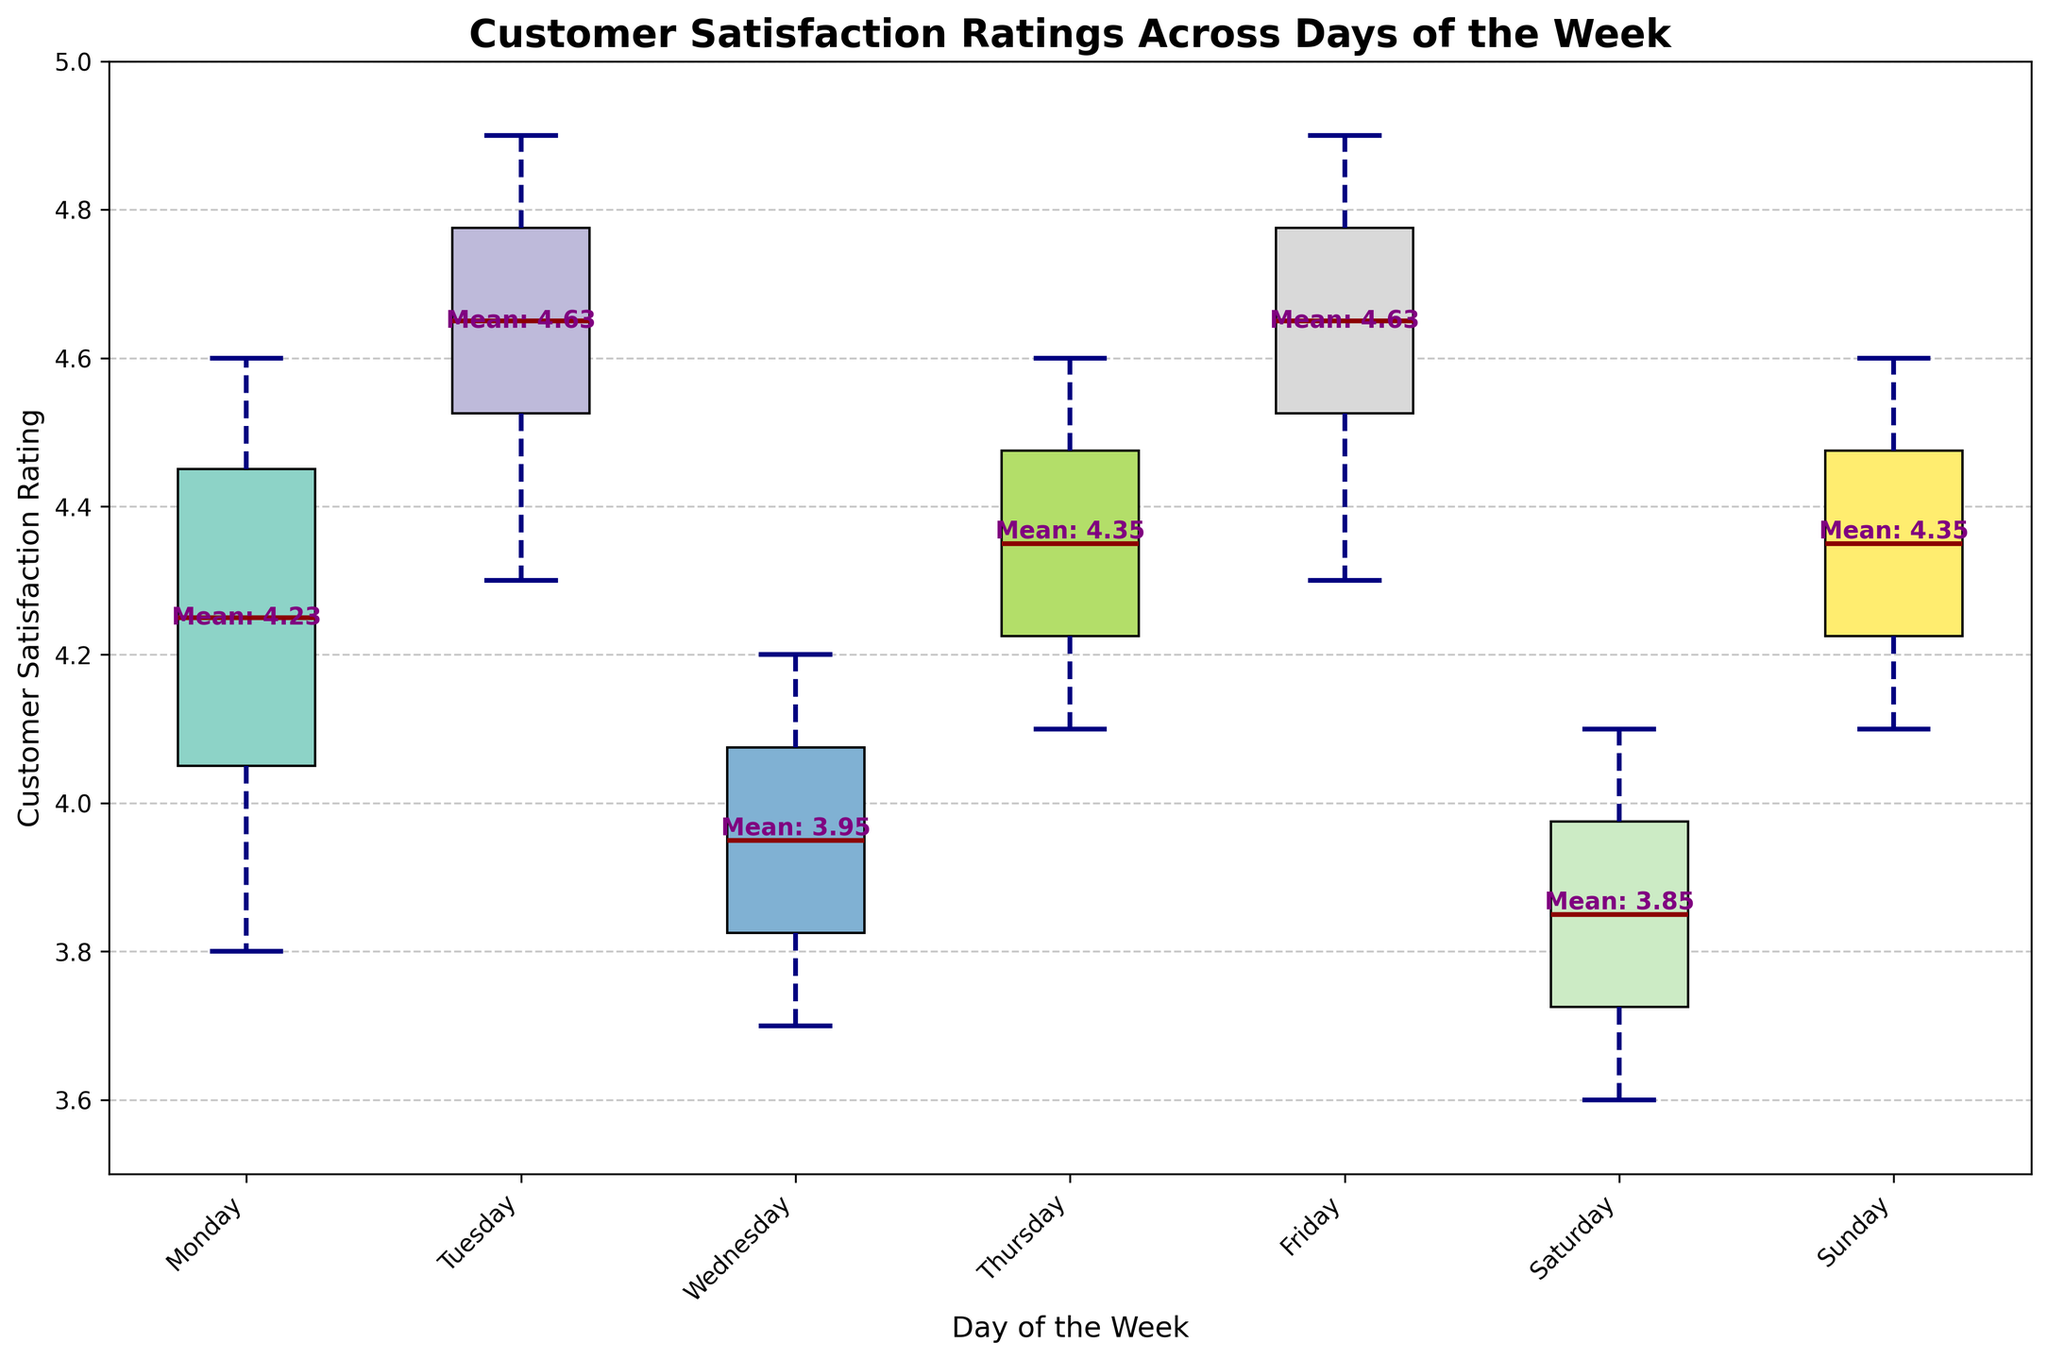what is the title of the plot? The title of the plot is located at the top center of the figure and typically indicates the main topic of the plot. Here, it states, "Customer Satisfaction Ratings Across Days of the Week."
Answer: Customer Satisfaction Ratings Across Days of the Week Which day has the highest median rating? By looking at the lines inside the boxes, which represent the median of the dataset, we can see that Friday's median is the highest among all days.
Answer: Friday What is the mean rating for Tuesday? The figure includes text annotations for the mean ratings of each day. The mean rating for Tuesday is shown as being approximately 4.63.
Answer: 4.63 How do the quartile ranges of Monday and Wednesday compare? The quartile range can be identified by the length of the boxes. Monday's box is shorter than Wednesday's, indicating that Monday has a smaller interquartile range compared to Wednesday.
Answer: Monday has a smaller interquartile range than Wednesday Which day shows the most variation in customer satisfaction ratings? Variation in ratings is depicted by the length of the whiskers. The day with the longest whiskers indicates the most variation. Here, Saturday has the longest whiskers, showing the most variation in ratings.
Answer: Saturday On which day is the median rating exactly at the center of the quartile range? When the median line divides the box into two equal parts, the median is at the center of the quartile range. For this plot, Thursday displays this characteristic.
Answer: Thursday Are there any outliers in the data for Sunday? Outliers are represented by individual points that fall outside the whiskers. For Sunday, there are no outliers shown.
Answer: No Which three days have the lowest average (mean) ratings? By looking at the text annotations for each day's mean, we can identify the days with the lowest mean ratings as Wednesday (4.12), Saturday (3.85), and Monday (4.07).
Answer: Wednesday, Saturday, Monday What are the color schemes of the boxes, and do they show any specific pattern related to the days? The boxes are colored using distinct colors without any particular pattern indicating a relationship to the days of the week. These colors are likely chosen for better visual distinction.
Answer: Distinct colors for visual distinction Is the median rating for Wednesday greater than the mean rating for Monday? By comparing the median line of Wednesday with the text annotation of the mean for Monday, we see that Wednesday's median (4.0) is not greater than the mean rating for Monday (4.07).
Answer: No 